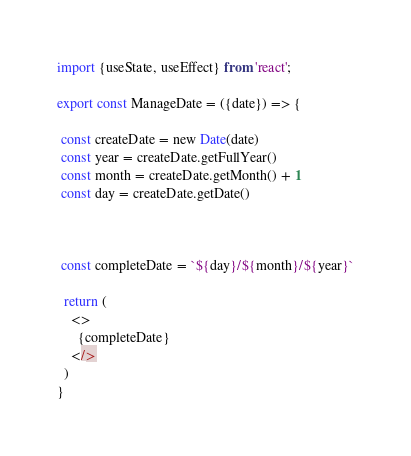Convert code to text. <code><loc_0><loc_0><loc_500><loc_500><_JavaScript_>import {useState, useEffect} from 'react';

export const ManageDate = ({date}) => {

 const createDate = new Date(date)
 const year = createDate.getFullYear()
 const month = createDate.getMonth() + 1
 const day = createDate.getDate()
 
 

 const completeDate = `${day}/${month}/${year}`

  return (
    <>
      {completeDate}
    </>
  )
}

</code> 